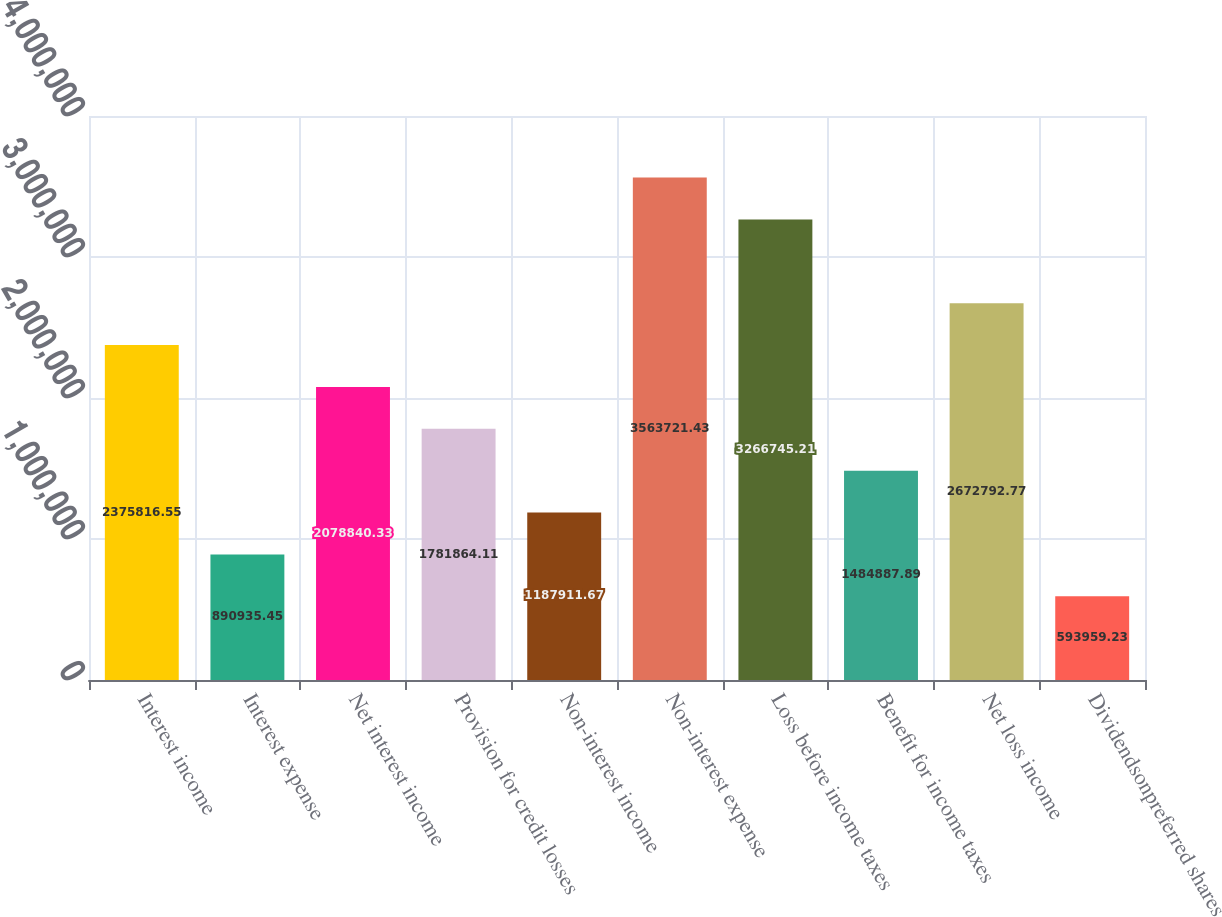Convert chart. <chart><loc_0><loc_0><loc_500><loc_500><bar_chart><fcel>Interest income<fcel>Interest expense<fcel>Net interest income<fcel>Provision for credit losses<fcel>Non-interest income<fcel>Non-interest expense<fcel>Loss before income taxes<fcel>Benefit for income taxes<fcel>Net loss income<fcel>Dividendsonpreferred shares<nl><fcel>2.37582e+06<fcel>890935<fcel>2.07884e+06<fcel>1.78186e+06<fcel>1.18791e+06<fcel>3.56372e+06<fcel>3.26675e+06<fcel>1.48489e+06<fcel>2.67279e+06<fcel>593959<nl></chart> 